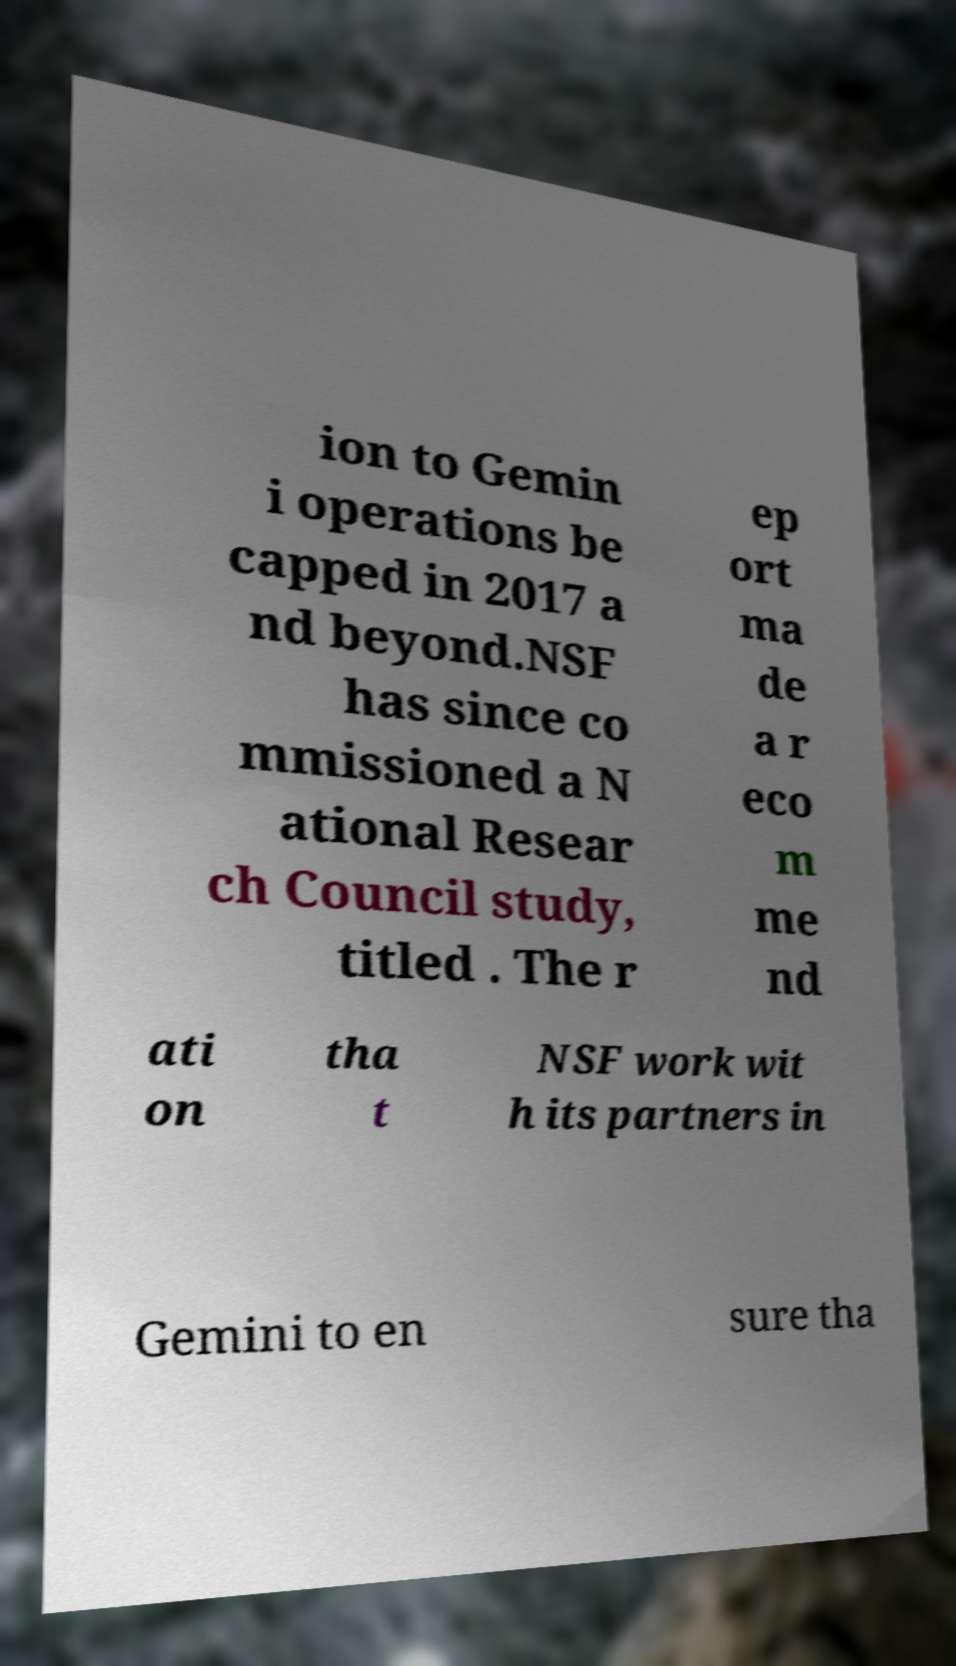Please read and relay the text visible in this image. What does it say? ion to Gemin i operations be capped in 2017 a nd beyond.NSF has since co mmissioned a N ational Resear ch Council study, titled . The r ep ort ma de a r eco m me nd ati on tha t NSF work wit h its partners in Gemini to en sure tha 